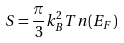Convert formula to latex. <formula><loc_0><loc_0><loc_500><loc_500>S = \frac { \pi } { 3 } k _ { B } ^ { 2 } T n ( E _ { F } )</formula> 